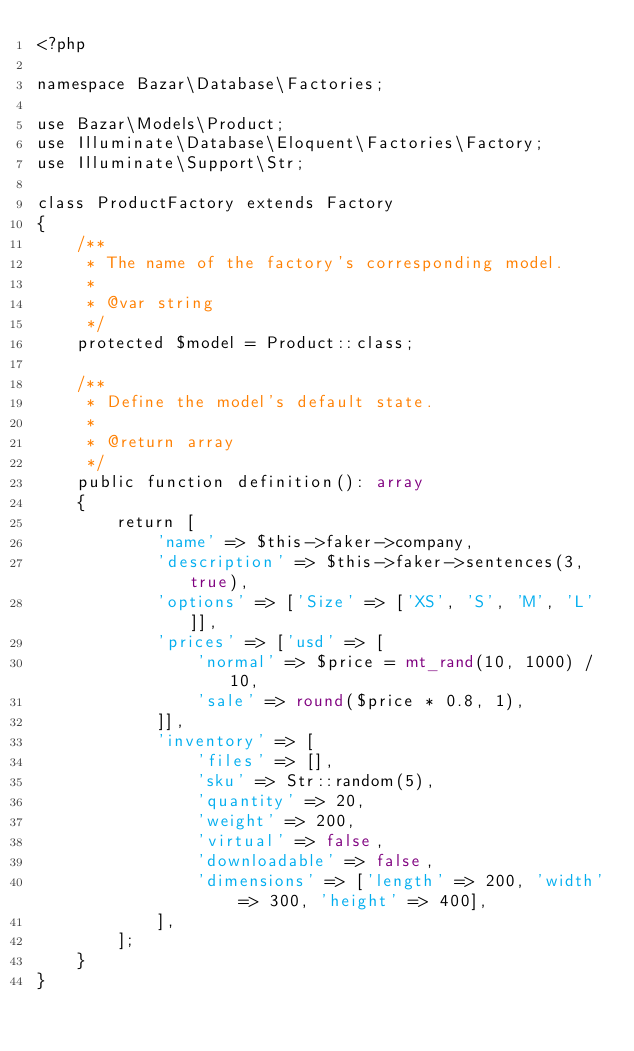Convert code to text. <code><loc_0><loc_0><loc_500><loc_500><_PHP_><?php

namespace Bazar\Database\Factories;

use Bazar\Models\Product;
use Illuminate\Database\Eloquent\Factories\Factory;
use Illuminate\Support\Str;

class ProductFactory extends Factory
{
    /**
     * The name of the factory's corresponding model.
     *
     * @var string
     */
    protected $model = Product::class;

    /**
     * Define the model's default state.
     *
     * @return array
     */
    public function definition(): array
    {
        return [
            'name' => $this->faker->company,
            'description' => $this->faker->sentences(3, true),
            'options' => ['Size' => ['XS', 'S', 'M', 'L']],
            'prices' => ['usd' => [
                'normal' => $price = mt_rand(10, 1000) / 10,
                'sale' => round($price * 0.8, 1),
            ]],
            'inventory' => [
                'files' => [],
                'sku' => Str::random(5),
                'quantity' => 20,
                'weight' => 200,
                'virtual' => false,
                'downloadable' => false,
                'dimensions' => ['length' => 200, 'width' => 300, 'height' => 400],
            ],
        ];
    }
}
</code> 